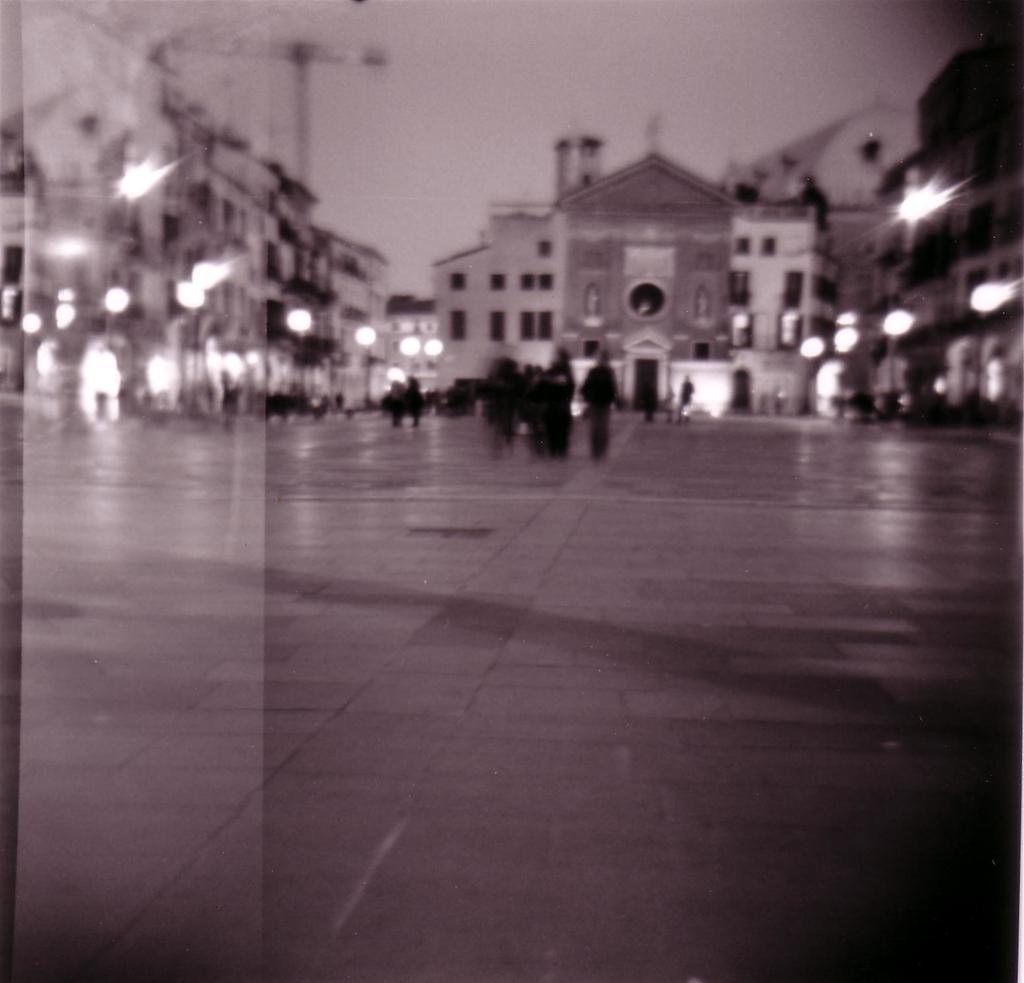What is the overall quality of the image? The image appears to be blurry. What type of structures can be seen in the image? There are buildings visible in the image. What can be observed in terms of illumination in the image? There are lights present in the image. What type of prose is being recited by the expert in the image? There is no expert or prose present in the image; it only features blurry buildings and lights. What type of underwear is being worn by the person in the image? There is no person present in the image, so it is impossible to determine what type of underwear they might be wearing. 